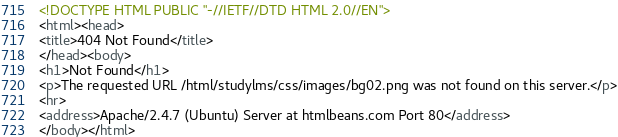Convert code to text. <code><loc_0><loc_0><loc_500><loc_500><_HTML_><!DOCTYPE HTML PUBLIC "-//IETF//DTD HTML 2.0//EN">
<html><head>
<title>404 Not Found</title>
</head><body>
<h1>Not Found</h1>
<p>The requested URL /html/studylms/css/images/bg02.png was not found on this server.</p>
<hr>
<address>Apache/2.4.7 (Ubuntu) Server at htmlbeans.com Port 80</address>
</body></html>
</code> 